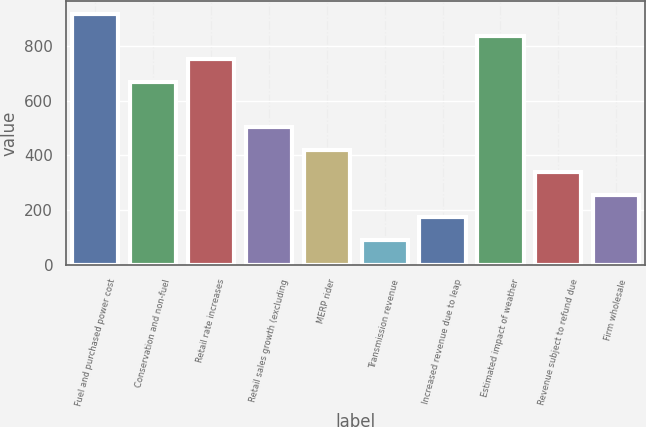<chart> <loc_0><loc_0><loc_500><loc_500><bar_chart><fcel>Fuel and purchased power cost<fcel>Conservation and non-fuel<fcel>Retail rate increases<fcel>Retail sales growth (excluding<fcel>MERP rider<fcel>Transmission revenue<fcel>Increased revenue due to leap<fcel>Estimated impact of weather<fcel>Revenue subject to refund due<fcel>Firm wholesale<nl><fcel>917.7<fcel>669.6<fcel>752.3<fcel>504.2<fcel>421.5<fcel>90.7<fcel>173.4<fcel>835<fcel>338.8<fcel>256.1<nl></chart> 